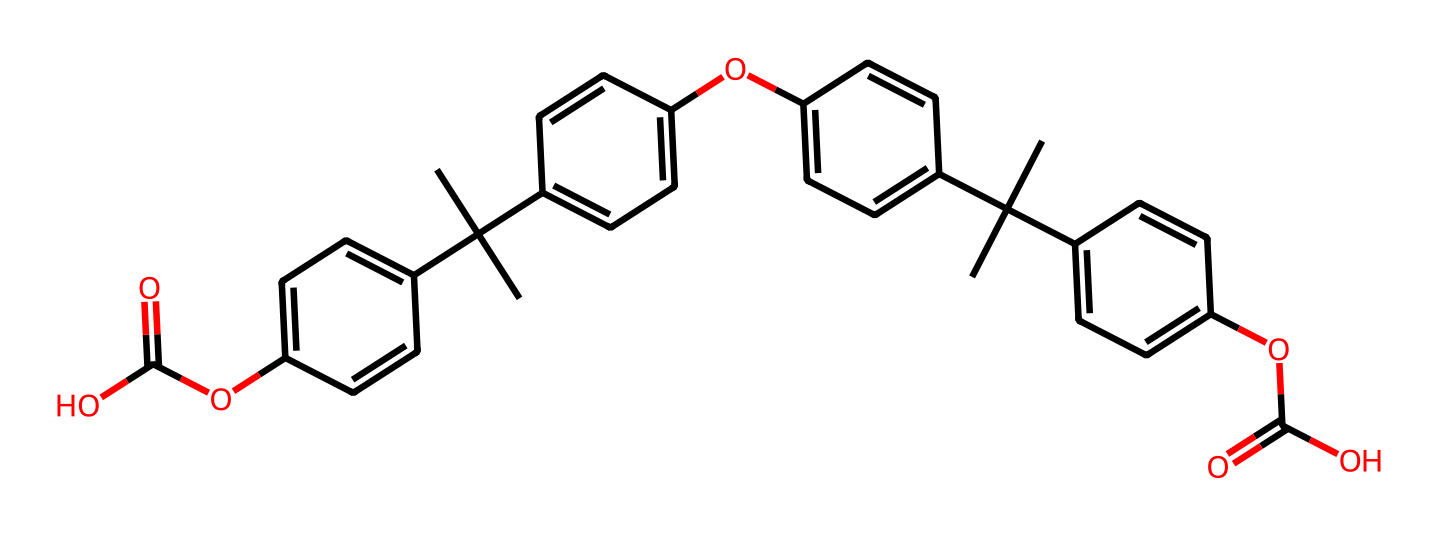What is the primary functional group present in this compound? The chemical structure shows multiple instances of ether functional groups represented by the -O- linkages between aromatic rings. This indicates that the primary functional group is ether.
Answer: ether How many carbon atoms are present in this compound? By analyzing the SMILES representation, we can count the number of 'C' atoms, which totals over 30 in the structure.
Answer: 30 What type of chemical is this compound categorized as? This compound does not dissociate into ions in solution, classifying it as a non-electrolyte. The presence of carbon-hydrogen and carbon-oxygen bonds further confirms this categorization.
Answer: non-electrolyte What is the molecular feature that most likely contributes to blue light filtering? The presence of conjugated double bonds in the aromatic rings allows for light absorption, which is crucial for filtering blue light. This configuration effectively interacts with blue light wavelengths.
Answer: conjugated double bonds How many ester groups are present in this compound? The structure includes two carbonyl groups directly attached to oxygen atoms (O), indicating the presence of 2 ester functional groups as part of its configuration.
Answer: 2 Does this compound have any hydroxy functional groups? The presence of -OH groups is evident from the aromatic hydroxyl structures present in the SMILES, confirming the existence of hydroxy functional groups in the compound.
Answer: yes 